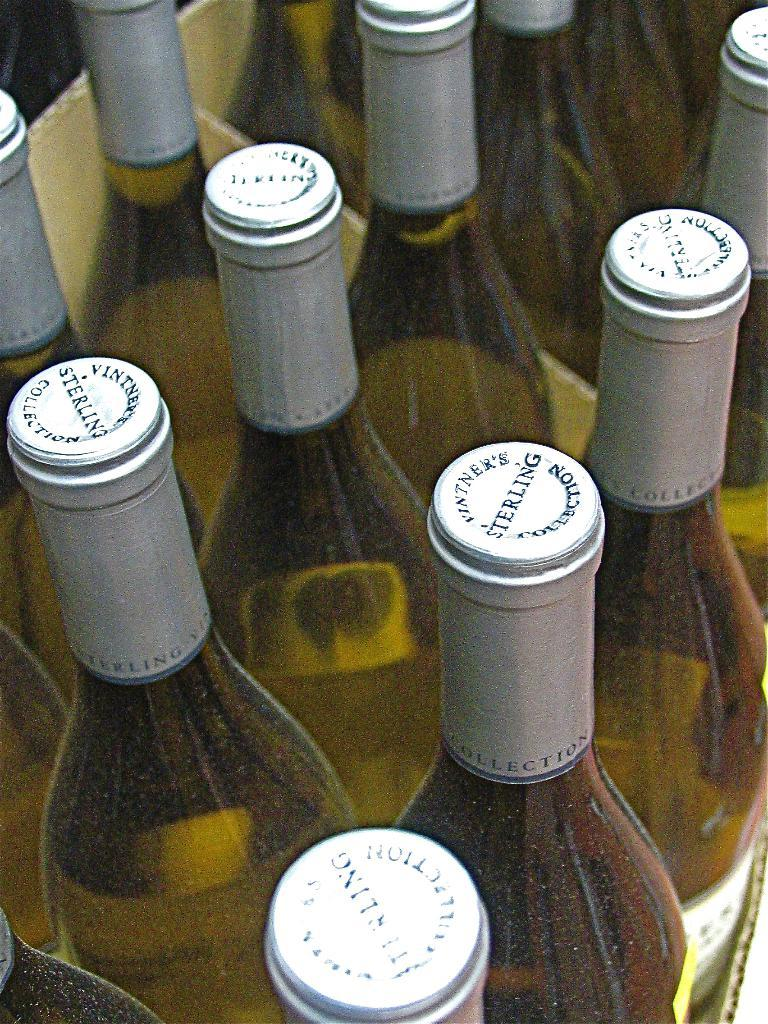<image>
Render a clear and concise summary of the photo. A few bottles of liquid that all have sterling on top 